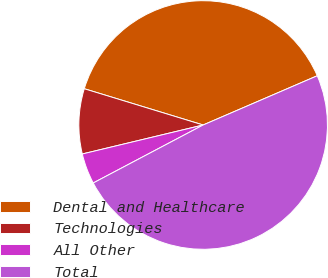Convert chart. <chart><loc_0><loc_0><loc_500><loc_500><pie_chart><fcel>Dental and Healthcare<fcel>Technologies<fcel>All Other<fcel>Total<nl><fcel>38.81%<fcel>8.46%<fcel>3.98%<fcel>48.76%<nl></chart> 